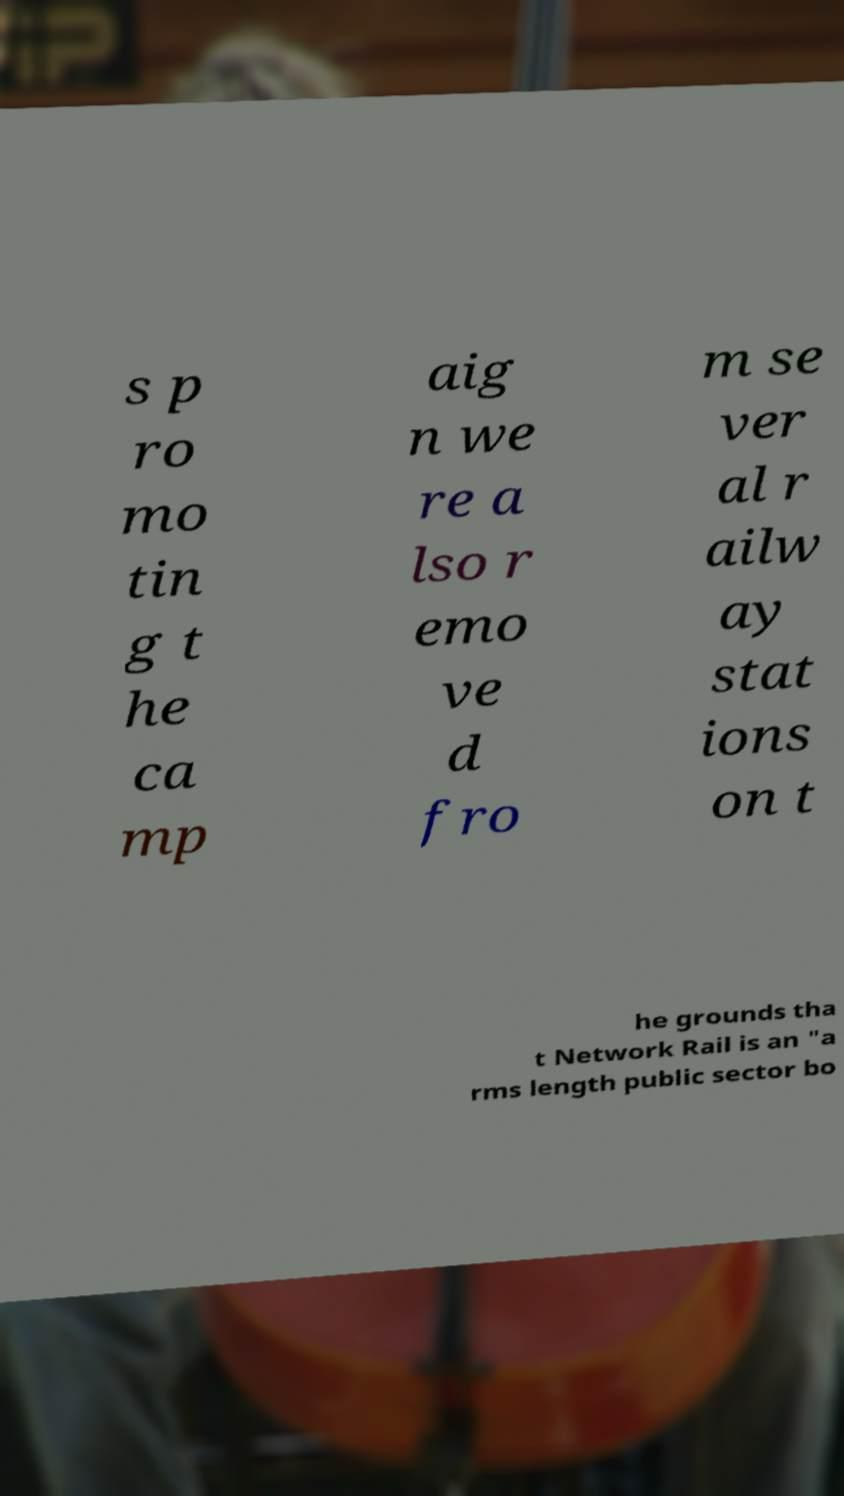Please identify and transcribe the text found in this image. s p ro mo tin g t he ca mp aig n we re a lso r emo ve d fro m se ver al r ailw ay stat ions on t he grounds tha t Network Rail is an "a rms length public sector bo 